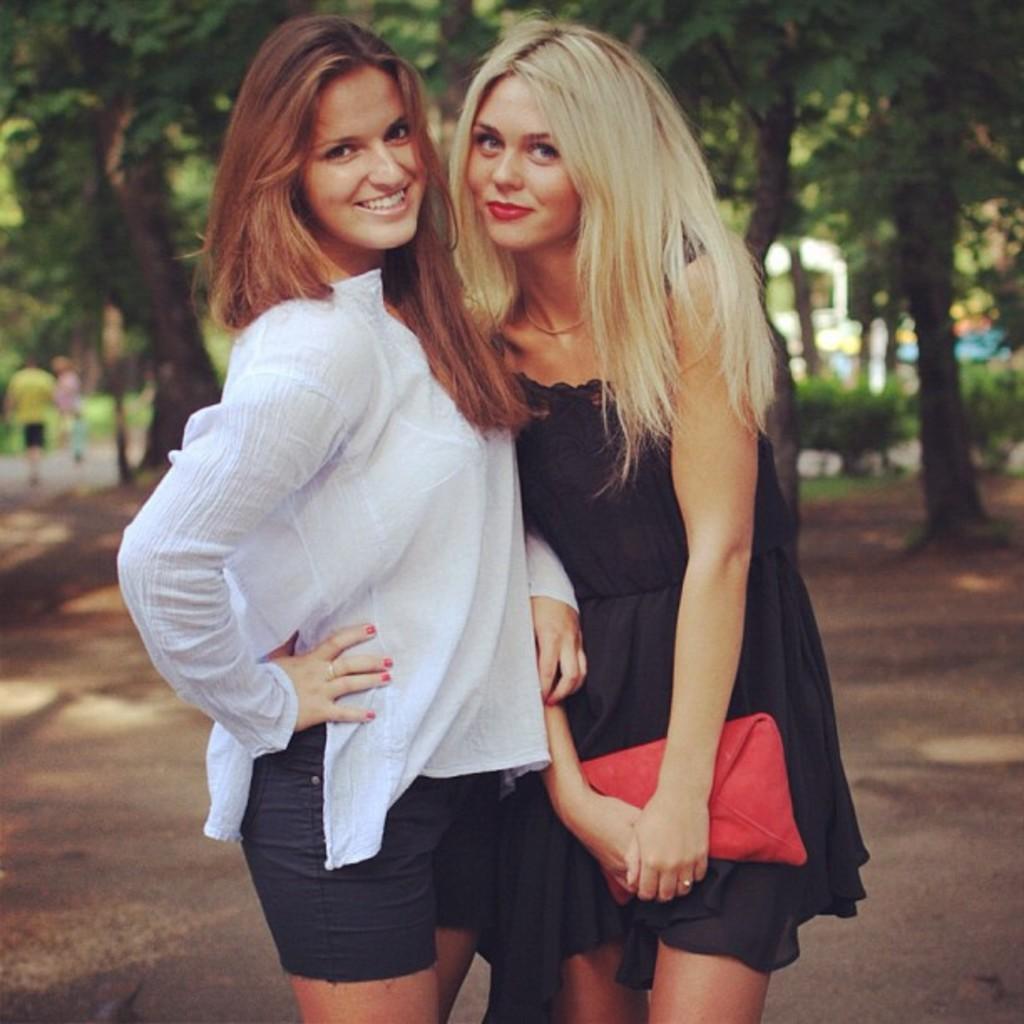Describe this image in one or two sentences. As we can see in the image in the front there are two people standing. The woman on the left side is wearing white color dress. The woman on the right side is wearing black color dress. In the background there are trees, plants and building. 